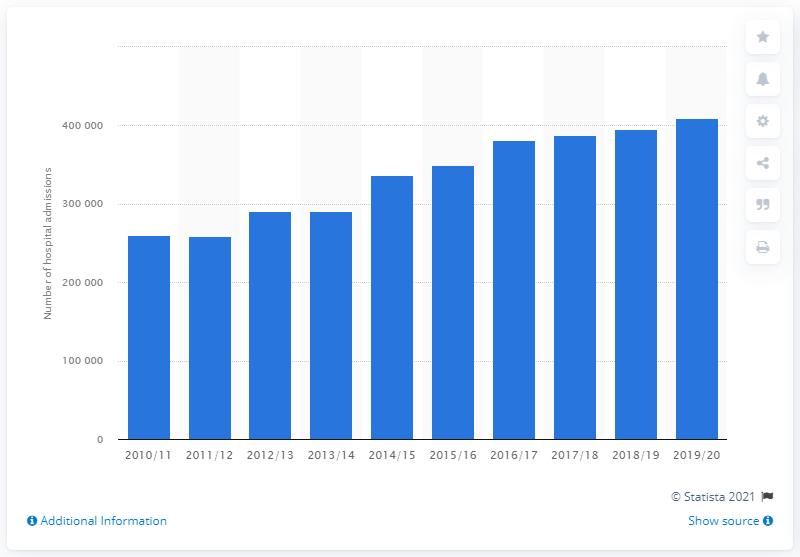Highlight a few significant elements in this photo. In 2010, a total of 259,286 adults were admitted to hospital for a respiratory disease caused by smoking. By 2020, it is estimated that approximately 410,320 adults were admitted to the hospital for a respiratory disease caused by smoking. 